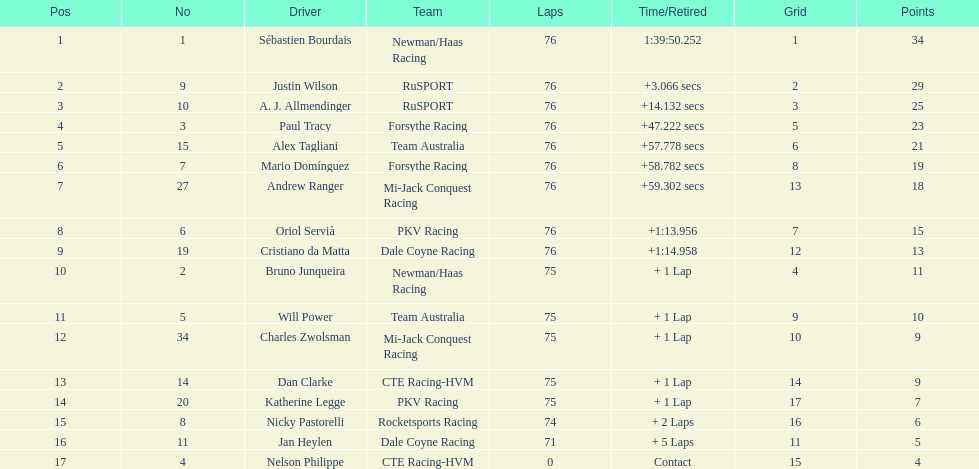Which driver earned the least amount of points. Nelson Philippe. 